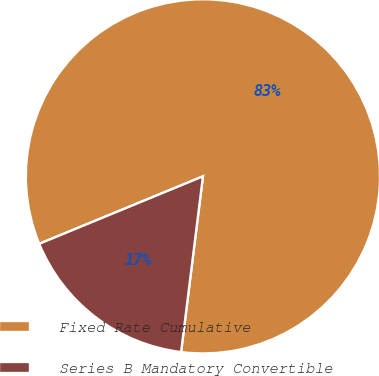Convert chart. <chart><loc_0><loc_0><loc_500><loc_500><pie_chart><fcel>Fixed Rate Cumulative<fcel>Series B Mandatory Convertible<nl><fcel>83.19%<fcel>16.81%<nl></chart> 